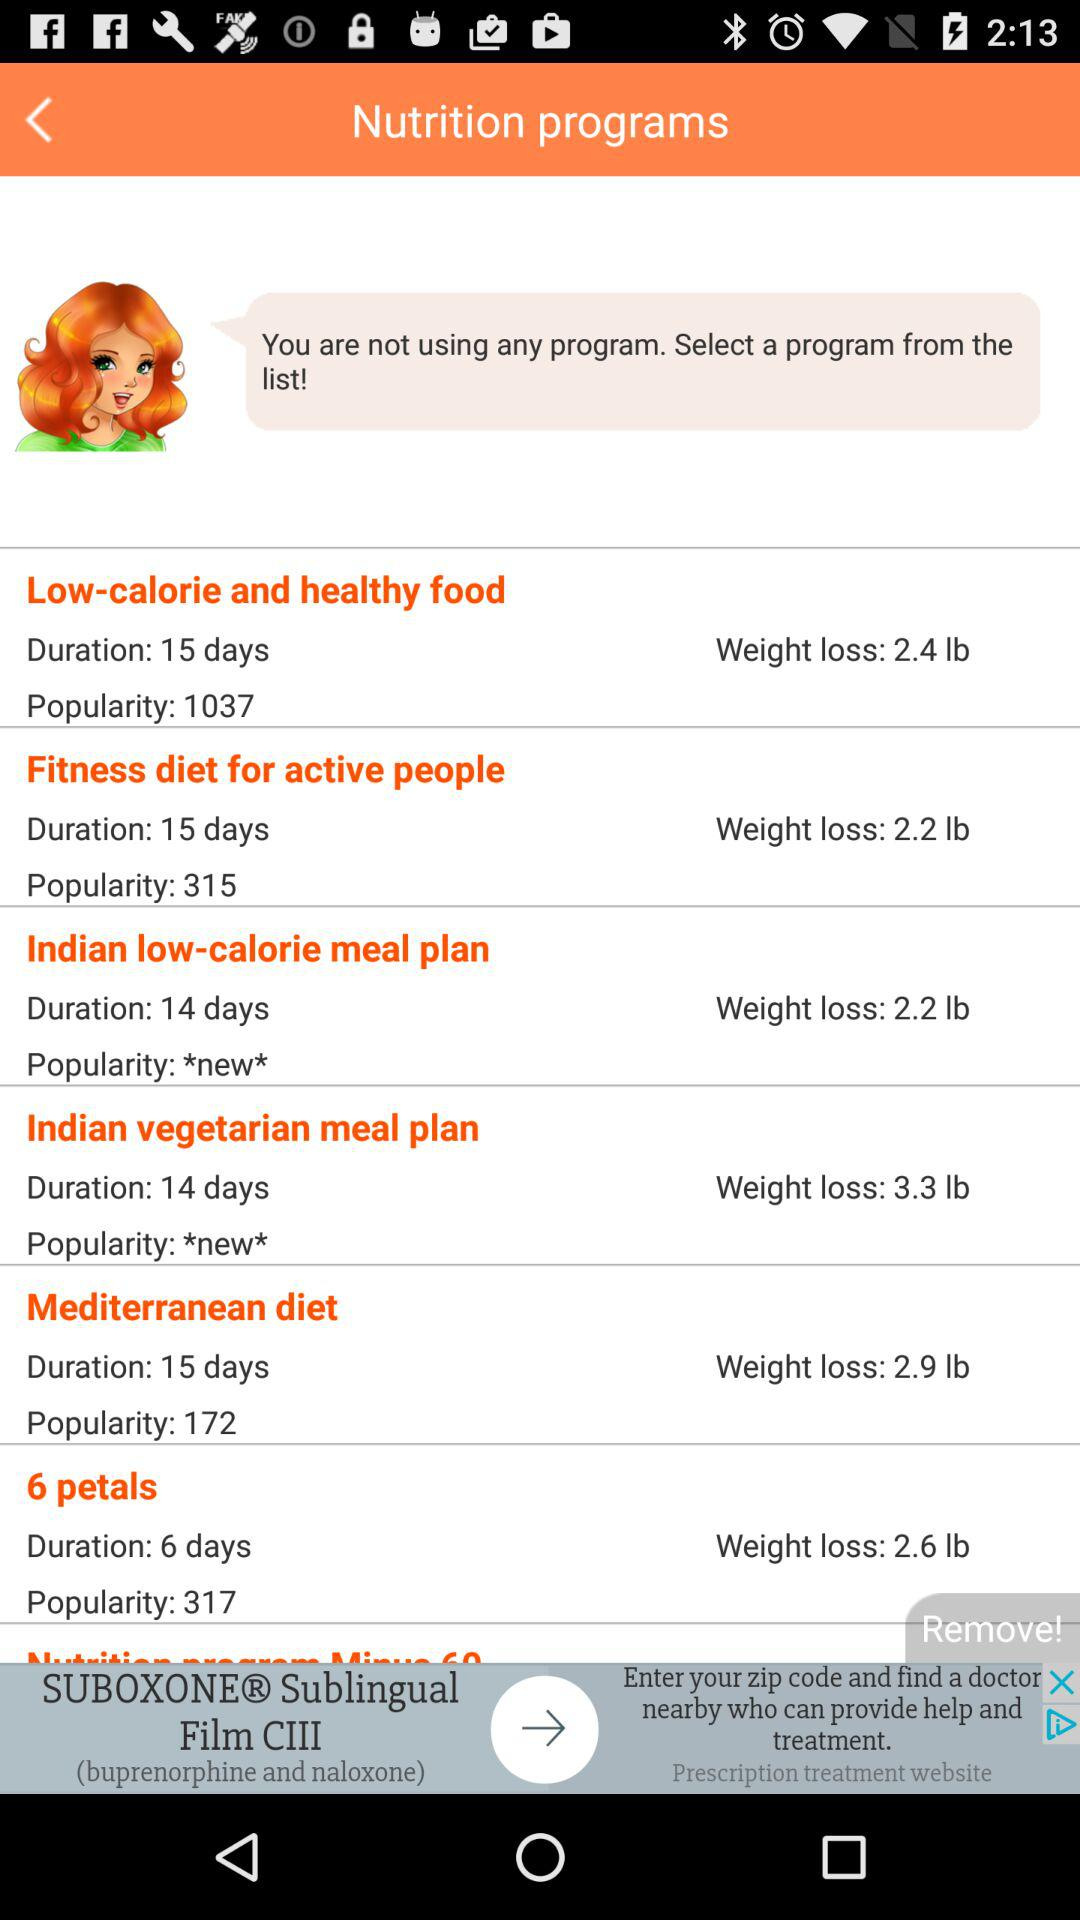What is the popularity of the "Fitness diet for active people"? The popularity of the "Fitness diet for active people" is 315. 